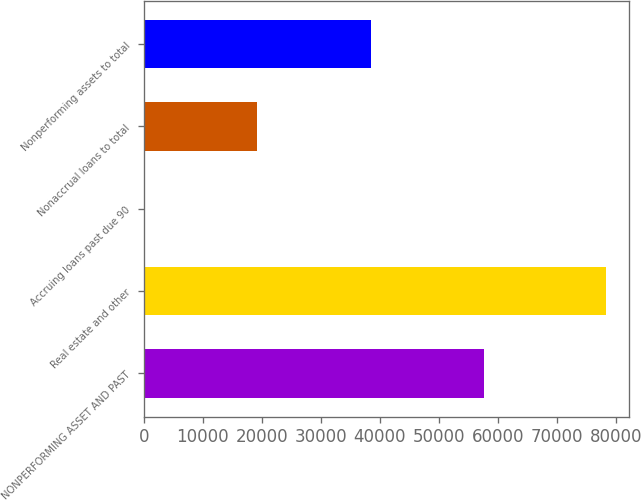<chart> <loc_0><loc_0><loc_500><loc_500><bar_chart><fcel>NONPERFORMING ASSET AND PAST<fcel>Real estate and other<fcel>Accruing loans past due 90<fcel>Nonaccrual loans to total<fcel>Nonperforming assets to total<nl><fcel>57733.1<fcel>78375<fcel>0.25<fcel>19244.5<fcel>38488.8<nl></chart> 